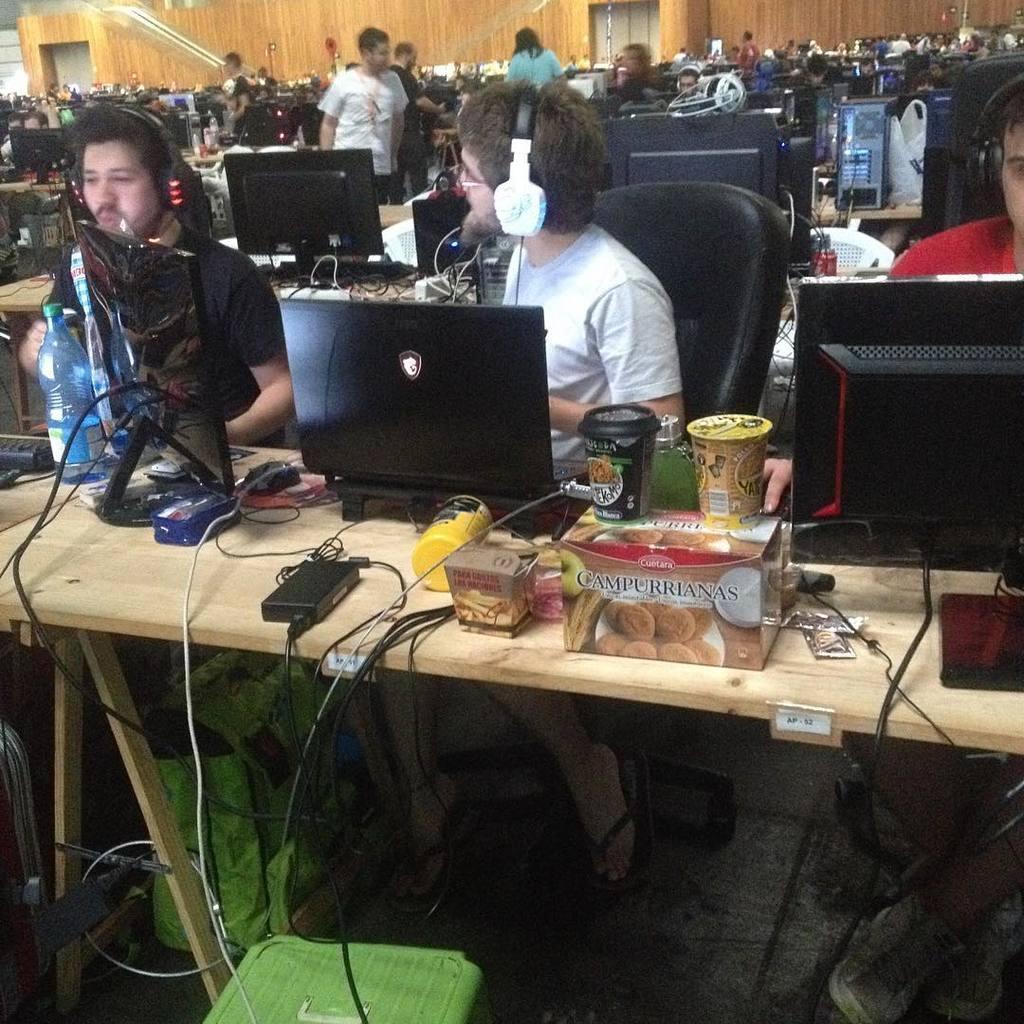How would you summarize this image in a sentence or two? In this image I can see number of people, tables and computer systems. I can also see most of them are wearing headphones. On this table I can see few boxes, few glasses and few bottles. 